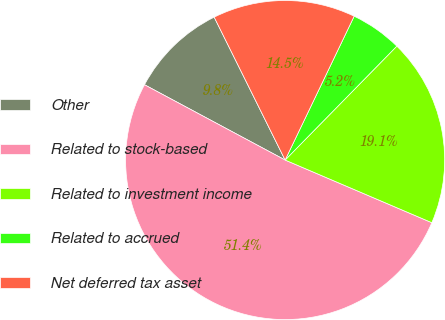Convert chart. <chart><loc_0><loc_0><loc_500><loc_500><pie_chart><fcel>Other<fcel>Related to stock-based<fcel>Related to investment income<fcel>Related to accrued<fcel>Net deferred tax asset<nl><fcel>9.84%<fcel>51.4%<fcel>19.08%<fcel>5.22%<fcel>14.46%<nl></chart> 